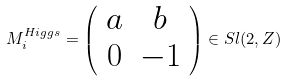Convert formula to latex. <formula><loc_0><loc_0><loc_500><loc_500>M _ { i } ^ { H i g g s } = \left ( \begin{array} { c c } a & b \\ 0 & - 1 \end{array} \right ) \in S l ( 2 , Z )</formula> 